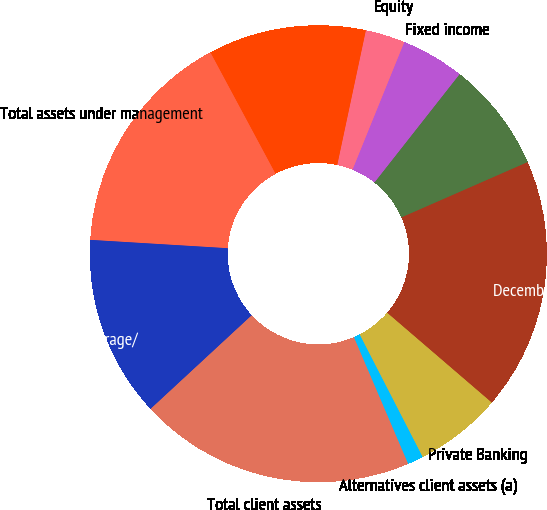<chart> <loc_0><loc_0><loc_500><loc_500><pie_chart><fcel>December 31 (in billions)<fcel>Liquidity<fcel>Fixed income<fcel>Equity<fcel>Multi-asset and alternatives<fcel>Total assets under management<fcel>Custody/brokerage/<fcel>Total client assets<fcel>Alternatives client assets (a)<fcel>Private Banking<nl><fcel>17.87%<fcel>7.82%<fcel>4.47%<fcel>2.8%<fcel>11.17%<fcel>16.2%<fcel>12.85%<fcel>19.55%<fcel>1.12%<fcel>6.15%<nl></chart> 